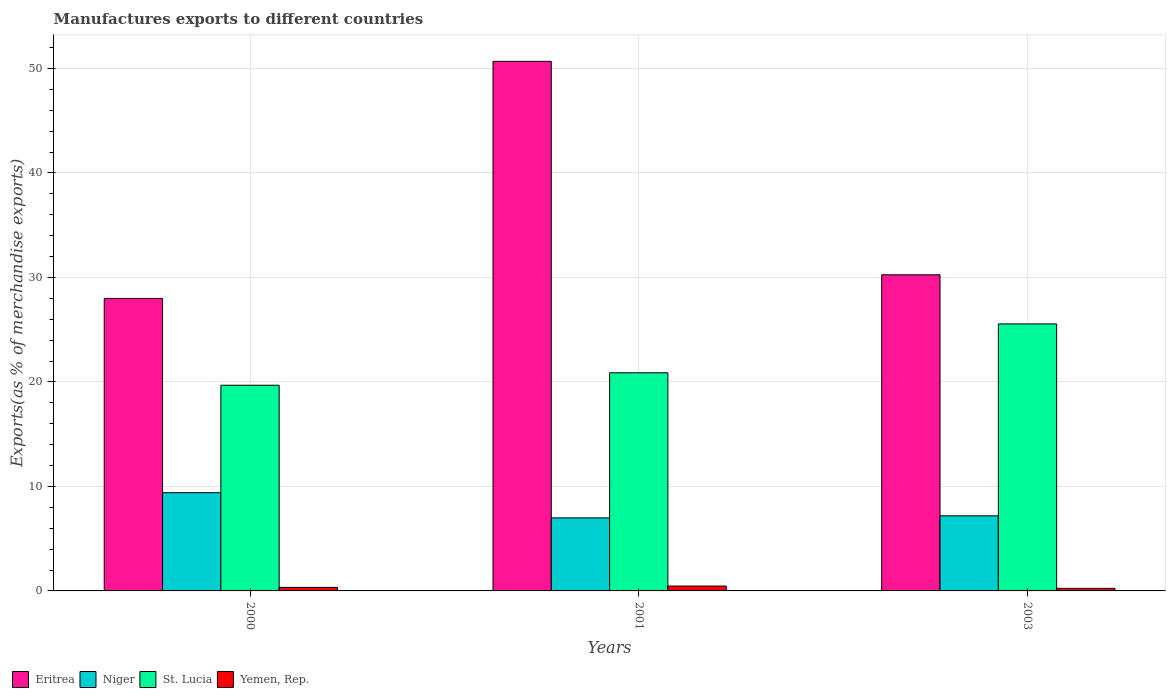How many groups of bars are there?
Provide a succinct answer. 3. Are the number of bars on each tick of the X-axis equal?
Your response must be concise. Yes. In how many cases, is the number of bars for a given year not equal to the number of legend labels?
Your answer should be very brief. 0. What is the percentage of exports to different countries in Niger in 2003?
Give a very brief answer. 7.19. Across all years, what is the maximum percentage of exports to different countries in Niger?
Give a very brief answer. 9.4. Across all years, what is the minimum percentage of exports to different countries in St. Lucia?
Make the answer very short. 19.68. In which year was the percentage of exports to different countries in Eritrea minimum?
Give a very brief answer. 2000. What is the total percentage of exports to different countries in Eritrea in the graph?
Offer a very short reply. 108.92. What is the difference between the percentage of exports to different countries in Niger in 2001 and that in 2003?
Keep it short and to the point. -0.2. What is the difference between the percentage of exports to different countries in Eritrea in 2000 and the percentage of exports to different countries in Niger in 2001?
Give a very brief answer. 21. What is the average percentage of exports to different countries in Yemen, Rep. per year?
Provide a short and direct response. 0.35. In the year 2003, what is the difference between the percentage of exports to different countries in Eritrea and percentage of exports to different countries in Yemen, Rep.?
Offer a very short reply. 30.01. In how many years, is the percentage of exports to different countries in St. Lucia greater than 14 %?
Offer a very short reply. 3. What is the ratio of the percentage of exports to different countries in St. Lucia in 2000 to that in 2003?
Ensure brevity in your answer.  0.77. Is the percentage of exports to different countries in St. Lucia in 2000 less than that in 2003?
Give a very brief answer. Yes. What is the difference between the highest and the second highest percentage of exports to different countries in St. Lucia?
Your answer should be compact. 4.67. What is the difference between the highest and the lowest percentage of exports to different countries in Eritrea?
Your response must be concise. 22.69. Is it the case that in every year, the sum of the percentage of exports to different countries in St. Lucia and percentage of exports to different countries in Yemen, Rep. is greater than the sum of percentage of exports to different countries in Niger and percentage of exports to different countries in Eritrea?
Provide a short and direct response. Yes. What does the 2nd bar from the left in 2003 represents?
Your answer should be very brief. Niger. What does the 2nd bar from the right in 2001 represents?
Keep it short and to the point. St. Lucia. Is it the case that in every year, the sum of the percentage of exports to different countries in Eritrea and percentage of exports to different countries in Niger is greater than the percentage of exports to different countries in St. Lucia?
Provide a short and direct response. Yes. How many years are there in the graph?
Your response must be concise. 3. What is the difference between two consecutive major ticks on the Y-axis?
Your answer should be very brief. 10. Are the values on the major ticks of Y-axis written in scientific E-notation?
Provide a succinct answer. No. Does the graph contain grids?
Ensure brevity in your answer.  Yes. Where does the legend appear in the graph?
Your answer should be compact. Bottom left. How many legend labels are there?
Offer a terse response. 4. What is the title of the graph?
Give a very brief answer. Manufactures exports to different countries. What is the label or title of the Y-axis?
Provide a short and direct response. Exports(as % of merchandise exports). What is the Exports(as % of merchandise exports) in Eritrea in 2000?
Offer a very short reply. 27.99. What is the Exports(as % of merchandise exports) of Niger in 2000?
Provide a succinct answer. 9.4. What is the Exports(as % of merchandise exports) in St. Lucia in 2000?
Your answer should be compact. 19.68. What is the Exports(as % of merchandise exports) in Yemen, Rep. in 2000?
Ensure brevity in your answer.  0.34. What is the Exports(as % of merchandise exports) of Eritrea in 2001?
Your response must be concise. 50.68. What is the Exports(as % of merchandise exports) in Niger in 2001?
Give a very brief answer. 6.99. What is the Exports(as % of merchandise exports) in St. Lucia in 2001?
Make the answer very short. 20.88. What is the Exports(as % of merchandise exports) in Yemen, Rep. in 2001?
Your answer should be very brief. 0.47. What is the Exports(as % of merchandise exports) in Eritrea in 2003?
Offer a very short reply. 30.25. What is the Exports(as % of merchandise exports) in Niger in 2003?
Offer a terse response. 7.19. What is the Exports(as % of merchandise exports) in St. Lucia in 2003?
Provide a succinct answer. 25.55. What is the Exports(as % of merchandise exports) in Yemen, Rep. in 2003?
Make the answer very short. 0.25. Across all years, what is the maximum Exports(as % of merchandise exports) in Eritrea?
Provide a succinct answer. 50.68. Across all years, what is the maximum Exports(as % of merchandise exports) in Niger?
Your answer should be very brief. 9.4. Across all years, what is the maximum Exports(as % of merchandise exports) in St. Lucia?
Your response must be concise. 25.55. Across all years, what is the maximum Exports(as % of merchandise exports) of Yemen, Rep.?
Give a very brief answer. 0.47. Across all years, what is the minimum Exports(as % of merchandise exports) in Eritrea?
Give a very brief answer. 27.99. Across all years, what is the minimum Exports(as % of merchandise exports) of Niger?
Your answer should be compact. 6.99. Across all years, what is the minimum Exports(as % of merchandise exports) in St. Lucia?
Ensure brevity in your answer.  19.68. Across all years, what is the minimum Exports(as % of merchandise exports) in Yemen, Rep.?
Provide a short and direct response. 0.25. What is the total Exports(as % of merchandise exports) of Eritrea in the graph?
Your response must be concise. 108.92. What is the total Exports(as % of merchandise exports) of Niger in the graph?
Keep it short and to the point. 23.57. What is the total Exports(as % of merchandise exports) of St. Lucia in the graph?
Your answer should be compact. 66.11. What is the total Exports(as % of merchandise exports) of Yemen, Rep. in the graph?
Your answer should be compact. 1.05. What is the difference between the Exports(as % of merchandise exports) in Eritrea in 2000 and that in 2001?
Your answer should be very brief. -22.69. What is the difference between the Exports(as % of merchandise exports) of Niger in 2000 and that in 2001?
Keep it short and to the point. 2.41. What is the difference between the Exports(as % of merchandise exports) of St. Lucia in 2000 and that in 2001?
Your answer should be very brief. -1.19. What is the difference between the Exports(as % of merchandise exports) in Yemen, Rep. in 2000 and that in 2001?
Your answer should be compact. -0.13. What is the difference between the Exports(as % of merchandise exports) of Eritrea in 2000 and that in 2003?
Make the answer very short. -2.26. What is the difference between the Exports(as % of merchandise exports) in Niger in 2000 and that in 2003?
Make the answer very short. 2.21. What is the difference between the Exports(as % of merchandise exports) of St. Lucia in 2000 and that in 2003?
Provide a short and direct response. -5.87. What is the difference between the Exports(as % of merchandise exports) of Yemen, Rep. in 2000 and that in 2003?
Ensure brevity in your answer.  0.09. What is the difference between the Exports(as % of merchandise exports) in Eritrea in 2001 and that in 2003?
Provide a short and direct response. 20.43. What is the difference between the Exports(as % of merchandise exports) of Niger in 2001 and that in 2003?
Your response must be concise. -0.2. What is the difference between the Exports(as % of merchandise exports) in St. Lucia in 2001 and that in 2003?
Ensure brevity in your answer.  -4.67. What is the difference between the Exports(as % of merchandise exports) in Yemen, Rep. in 2001 and that in 2003?
Offer a very short reply. 0.22. What is the difference between the Exports(as % of merchandise exports) in Eritrea in 2000 and the Exports(as % of merchandise exports) in Niger in 2001?
Keep it short and to the point. 21. What is the difference between the Exports(as % of merchandise exports) of Eritrea in 2000 and the Exports(as % of merchandise exports) of St. Lucia in 2001?
Offer a terse response. 7.12. What is the difference between the Exports(as % of merchandise exports) in Eritrea in 2000 and the Exports(as % of merchandise exports) in Yemen, Rep. in 2001?
Offer a terse response. 27.52. What is the difference between the Exports(as % of merchandise exports) of Niger in 2000 and the Exports(as % of merchandise exports) of St. Lucia in 2001?
Provide a short and direct response. -11.48. What is the difference between the Exports(as % of merchandise exports) of Niger in 2000 and the Exports(as % of merchandise exports) of Yemen, Rep. in 2001?
Keep it short and to the point. 8.93. What is the difference between the Exports(as % of merchandise exports) in St. Lucia in 2000 and the Exports(as % of merchandise exports) in Yemen, Rep. in 2001?
Make the answer very short. 19.22. What is the difference between the Exports(as % of merchandise exports) in Eritrea in 2000 and the Exports(as % of merchandise exports) in Niger in 2003?
Make the answer very short. 20.81. What is the difference between the Exports(as % of merchandise exports) in Eritrea in 2000 and the Exports(as % of merchandise exports) in St. Lucia in 2003?
Your response must be concise. 2.44. What is the difference between the Exports(as % of merchandise exports) of Eritrea in 2000 and the Exports(as % of merchandise exports) of Yemen, Rep. in 2003?
Your answer should be compact. 27.74. What is the difference between the Exports(as % of merchandise exports) in Niger in 2000 and the Exports(as % of merchandise exports) in St. Lucia in 2003?
Make the answer very short. -16.15. What is the difference between the Exports(as % of merchandise exports) in Niger in 2000 and the Exports(as % of merchandise exports) in Yemen, Rep. in 2003?
Your answer should be very brief. 9.15. What is the difference between the Exports(as % of merchandise exports) of St. Lucia in 2000 and the Exports(as % of merchandise exports) of Yemen, Rep. in 2003?
Offer a very short reply. 19.44. What is the difference between the Exports(as % of merchandise exports) of Eritrea in 2001 and the Exports(as % of merchandise exports) of Niger in 2003?
Provide a succinct answer. 43.49. What is the difference between the Exports(as % of merchandise exports) in Eritrea in 2001 and the Exports(as % of merchandise exports) in St. Lucia in 2003?
Offer a terse response. 25.13. What is the difference between the Exports(as % of merchandise exports) in Eritrea in 2001 and the Exports(as % of merchandise exports) in Yemen, Rep. in 2003?
Make the answer very short. 50.43. What is the difference between the Exports(as % of merchandise exports) of Niger in 2001 and the Exports(as % of merchandise exports) of St. Lucia in 2003?
Keep it short and to the point. -18.56. What is the difference between the Exports(as % of merchandise exports) in Niger in 2001 and the Exports(as % of merchandise exports) in Yemen, Rep. in 2003?
Make the answer very short. 6.74. What is the difference between the Exports(as % of merchandise exports) in St. Lucia in 2001 and the Exports(as % of merchandise exports) in Yemen, Rep. in 2003?
Your answer should be very brief. 20.63. What is the average Exports(as % of merchandise exports) of Eritrea per year?
Provide a short and direct response. 36.31. What is the average Exports(as % of merchandise exports) of Niger per year?
Your answer should be very brief. 7.86. What is the average Exports(as % of merchandise exports) in St. Lucia per year?
Offer a very short reply. 22.04. What is the average Exports(as % of merchandise exports) of Yemen, Rep. per year?
Offer a terse response. 0.35. In the year 2000, what is the difference between the Exports(as % of merchandise exports) in Eritrea and Exports(as % of merchandise exports) in Niger?
Make the answer very short. 18.59. In the year 2000, what is the difference between the Exports(as % of merchandise exports) in Eritrea and Exports(as % of merchandise exports) in St. Lucia?
Provide a succinct answer. 8.31. In the year 2000, what is the difference between the Exports(as % of merchandise exports) in Eritrea and Exports(as % of merchandise exports) in Yemen, Rep.?
Make the answer very short. 27.65. In the year 2000, what is the difference between the Exports(as % of merchandise exports) in Niger and Exports(as % of merchandise exports) in St. Lucia?
Make the answer very short. -10.28. In the year 2000, what is the difference between the Exports(as % of merchandise exports) in Niger and Exports(as % of merchandise exports) in Yemen, Rep.?
Your answer should be very brief. 9.06. In the year 2000, what is the difference between the Exports(as % of merchandise exports) in St. Lucia and Exports(as % of merchandise exports) in Yemen, Rep.?
Your answer should be very brief. 19.35. In the year 2001, what is the difference between the Exports(as % of merchandise exports) in Eritrea and Exports(as % of merchandise exports) in Niger?
Your answer should be compact. 43.69. In the year 2001, what is the difference between the Exports(as % of merchandise exports) in Eritrea and Exports(as % of merchandise exports) in St. Lucia?
Offer a very short reply. 29.8. In the year 2001, what is the difference between the Exports(as % of merchandise exports) of Eritrea and Exports(as % of merchandise exports) of Yemen, Rep.?
Provide a short and direct response. 50.21. In the year 2001, what is the difference between the Exports(as % of merchandise exports) of Niger and Exports(as % of merchandise exports) of St. Lucia?
Keep it short and to the point. -13.89. In the year 2001, what is the difference between the Exports(as % of merchandise exports) in Niger and Exports(as % of merchandise exports) in Yemen, Rep.?
Offer a terse response. 6.52. In the year 2001, what is the difference between the Exports(as % of merchandise exports) of St. Lucia and Exports(as % of merchandise exports) of Yemen, Rep.?
Provide a succinct answer. 20.41. In the year 2003, what is the difference between the Exports(as % of merchandise exports) in Eritrea and Exports(as % of merchandise exports) in Niger?
Provide a short and direct response. 23.07. In the year 2003, what is the difference between the Exports(as % of merchandise exports) of Eritrea and Exports(as % of merchandise exports) of St. Lucia?
Offer a terse response. 4.7. In the year 2003, what is the difference between the Exports(as % of merchandise exports) of Eritrea and Exports(as % of merchandise exports) of Yemen, Rep.?
Your response must be concise. 30.01. In the year 2003, what is the difference between the Exports(as % of merchandise exports) in Niger and Exports(as % of merchandise exports) in St. Lucia?
Provide a short and direct response. -18.37. In the year 2003, what is the difference between the Exports(as % of merchandise exports) in Niger and Exports(as % of merchandise exports) in Yemen, Rep.?
Make the answer very short. 6.94. In the year 2003, what is the difference between the Exports(as % of merchandise exports) in St. Lucia and Exports(as % of merchandise exports) in Yemen, Rep.?
Ensure brevity in your answer.  25.3. What is the ratio of the Exports(as % of merchandise exports) of Eritrea in 2000 to that in 2001?
Your answer should be very brief. 0.55. What is the ratio of the Exports(as % of merchandise exports) of Niger in 2000 to that in 2001?
Make the answer very short. 1.35. What is the ratio of the Exports(as % of merchandise exports) of St. Lucia in 2000 to that in 2001?
Provide a short and direct response. 0.94. What is the ratio of the Exports(as % of merchandise exports) of Yemen, Rep. in 2000 to that in 2001?
Offer a very short reply. 0.72. What is the ratio of the Exports(as % of merchandise exports) of Eritrea in 2000 to that in 2003?
Offer a terse response. 0.93. What is the ratio of the Exports(as % of merchandise exports) of Niger in 2000 to that in 2003?
Keep it short and to the point. 1.31. What is the ratio of the Exports(as % of merchandise exports) of St. Lucia in 2000 to that in 2003?
Give a very brief answer. 0.77. What is the ratio of the Exports(as % of merchandise exports) of Yemen, Rep. in 2000 to that in 2003?
Give a very brief answer. 1.37. What is the ratio of the Exports(as % of merchandise exports) in Eritrea in 2001 to that in 2003?
Provide a short and direct response. 1.68. What is the ratio of the Exports(as % of merchandise exports) of Niger in 2001 to that in 2003?
Give a very brief answer. 0.97. What is the ratio of the Exports(as % of merchandise exports) in St. Lucia in 2001 to that in 2003?
Keep it short and to the point. 0.82. What is the ratio of the Exports(as % of merchandise exports) in Yemen, Rep. in 2001 to that in 2003?
Give a very brief answer. 1.89. What is the difference between the highest and the second highest Exports(as % of merchandise exports) in Eritrea?
Your answer should be very brief. 20.43. What is the difference between the highest and the second highest Exports(as % of merchandise exports) in Niger?
Provide a short and direct response. 2.21. What is the difference between the highest and the second highest Exports(as % of merchandise exports) of St. Lucia?
Keep it short and to the point. 4.67. What is the difference between the highest and the second highest Exports(as % of merchandise exports) of Yemen, Rep.?
Ensure brevity in your answer.  0.13. What is the difference between the highest and the lowest Exports(as % of merchandise exports) in Eritrea?
Provide a short and direct response. 22.69. What is the difference between the highest and the lowest Exports(as % of merchandise exports) in Niger?
Offer a terse response. 2.41. What is the difference between the highest and the lowest Exports(as % of merchandise exports) of St. Lucia?
Your answer should be compact. 5.87. What is the difference between the highest and the lowest Exports(as % of merchandise exports) in Yemen, Rep.?
Give a very brief answer. 0.22. 